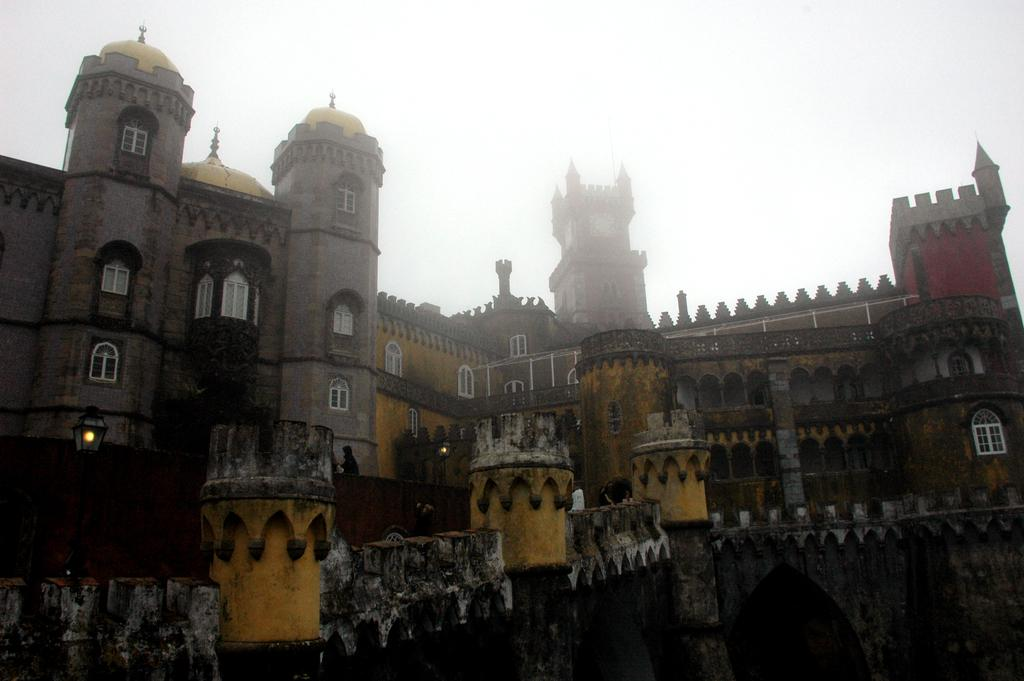What is the main subject of the image? The image depicts Pena National Palace. What can be seen in the image besides the palace? There are lights and poles visible in the image. Are there any people in the image? Yes, there is a group of people standing in the image. What is visible in the background of the image? The sky is visible in the image. What type of board game is being played by the people in the image? There is no board game visible in the image; it depicts Pena National Palace with lights, poles, and a group of people. What kind of seeds are being planted by the people in the image? There is no indication of planting or seeds in the image; it shows Pena National Palace with lights, poles, and a group of people. 